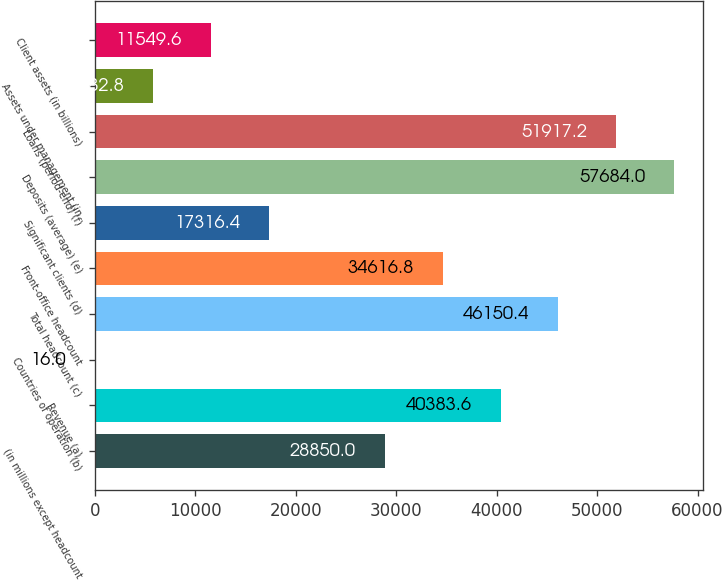Convert chart. <chart><loc_0><loc_0><loc_500><loc_500><bar_chart><fcel>(in millions except headcount<fcel>Revenue (a)<fcel>Countries of operation (b)<fcel>Total headcount (c)<fcel>Front-office headcount<fcel>Significant clients (d)<fcel>Deposits (average) (e)<fcel>Loans (period-end) (f)<fcel>Assets under management (in<fcel>Client assets (in billions)<nl><fcel>28850<fcel>40383.6<fcel>16<fcel>46150.4<fcel>34616.8<fcel>17316.4<fcel>57684<fcel>51917.2<fcel>5782.8<fcel>11549.6<nl></chart> 